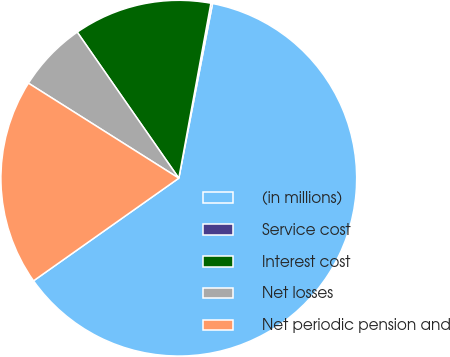<chart> <loc_0><loc_0><loc_500><loc_500><pie_chart><fcel>(in millions)<fcel>Service cost<fcel>Interest cost<fcel>Net losses<fcel>Net periodic pension and<nl><fcel>62.17%<fcel>0.15%<fcel>12.56%<fcel>6.36%<fcel>18.76%<nl></chart> 